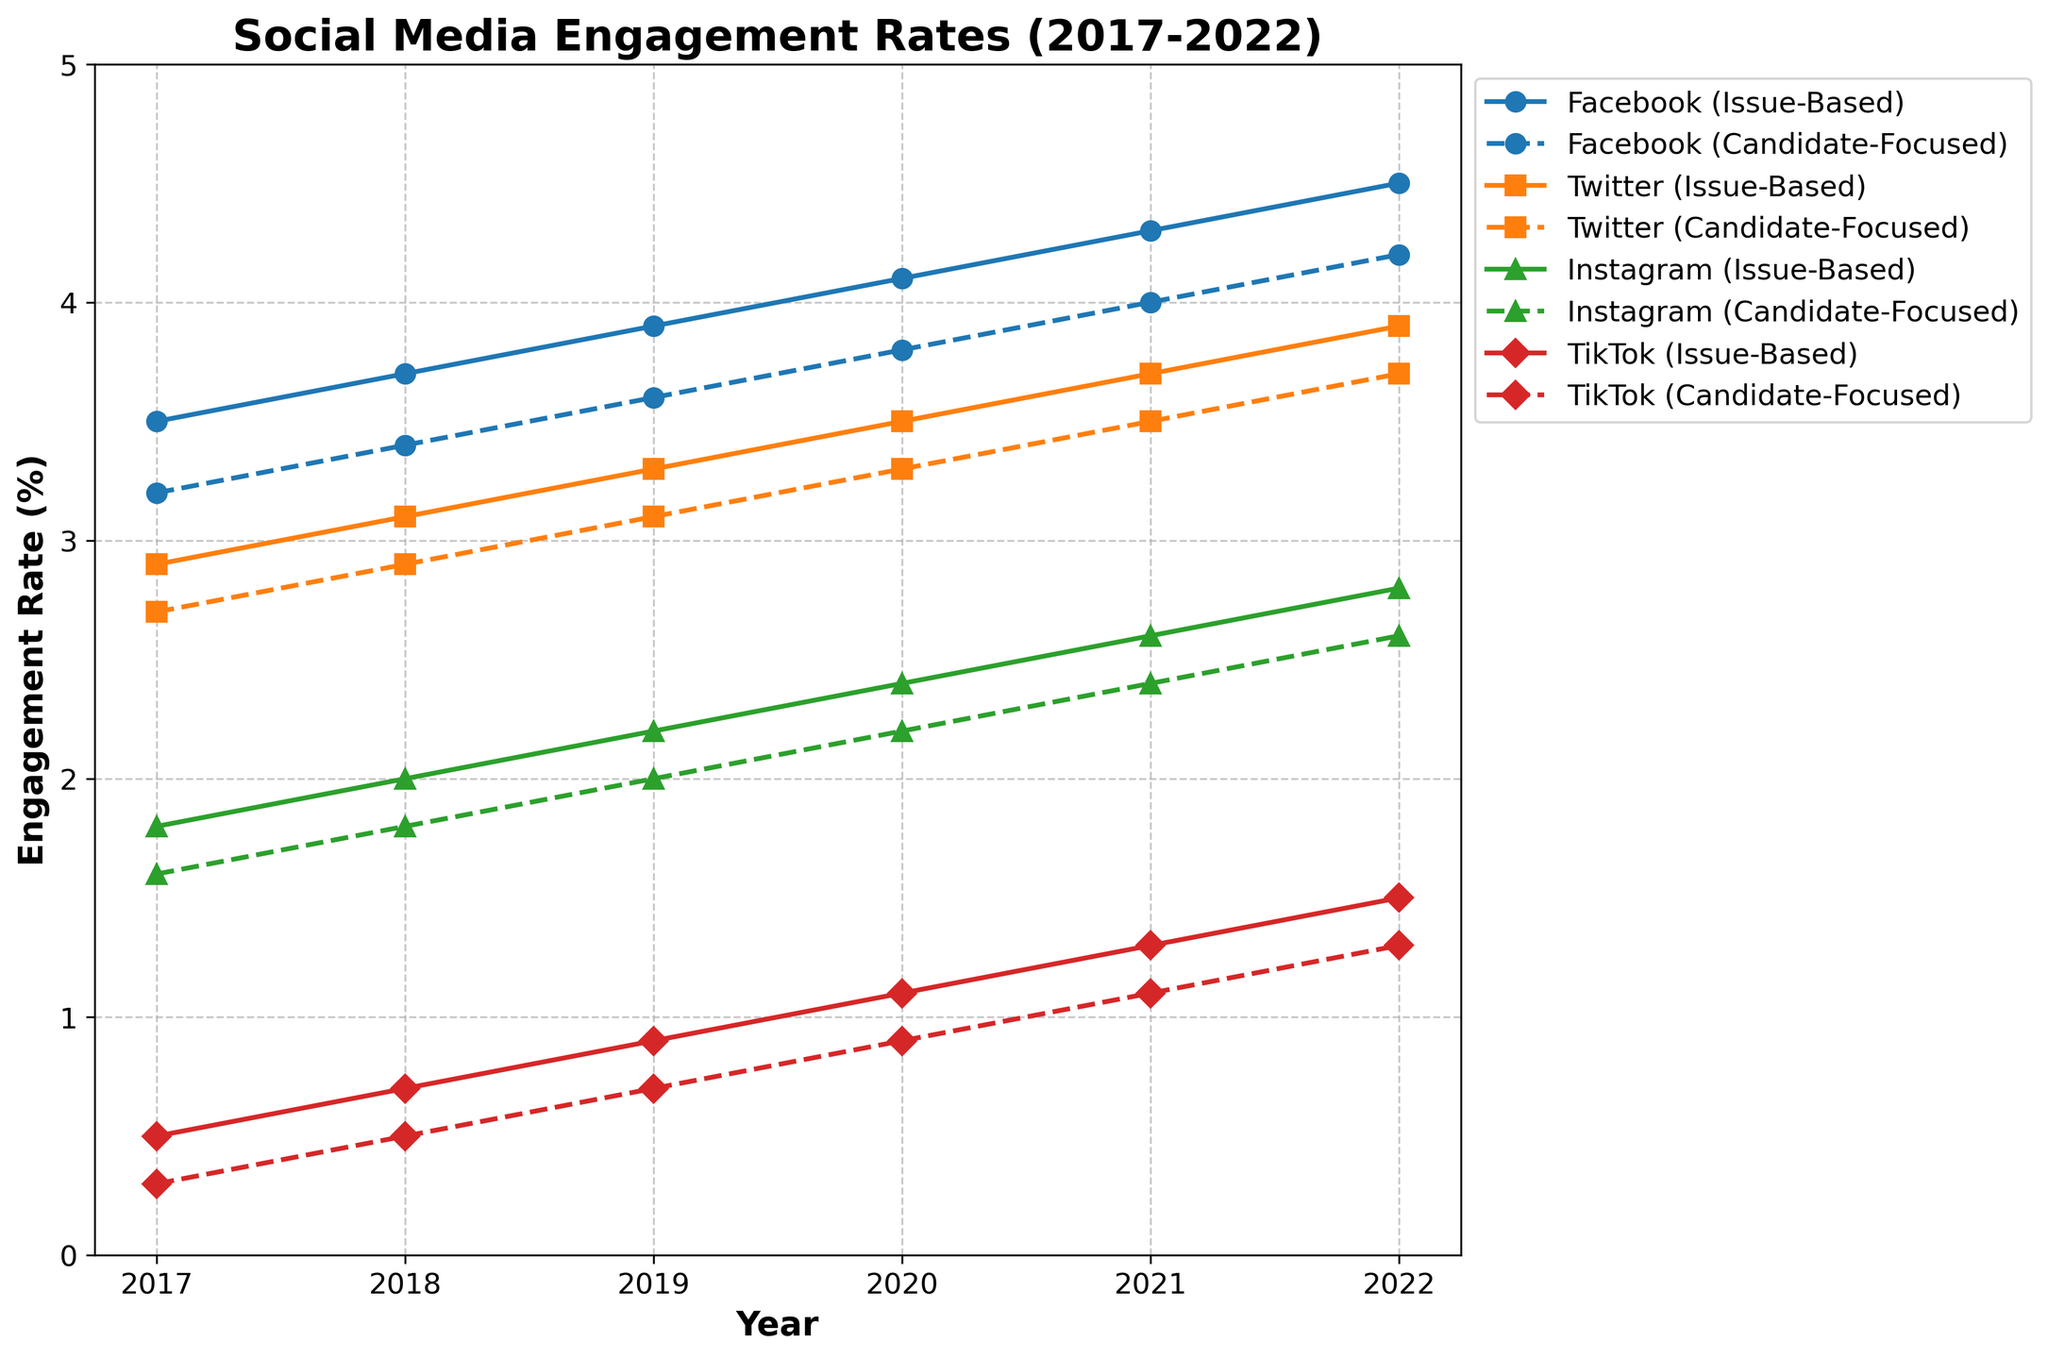What is the trend in engagement rates on Facebook for issue-based messaging from 2017 to 2022? The engagement rate on Facebook for issue-based messaging shows a steady increase from 3.5% in 2017 to 4.5% in 2022.
Answer: Increasing Which social media platform had the highest engagement rate for candidate-focused messaging in 2020? In 2020, Facebook had the highest engagement rate for candidate-focused messaging at 3.8%.
Answer: Facebook How does the engagement rate for issue-based messaging on TikTok in 2019 compare to that on Instagram in the same year? The engagement rate for issue-based messaging on TikTok in 2019 was 0.9%, while on Instagram, it was 2.2%. TikTok's rate is lower than Instagram's.
Answer: TikTok's rate is lower Is there any platform where issue-based messaging had a lower engagement rate than candidate-focused messaging in any year? Across all platforms and years from 2017 to 2022, issue-based messaging consistently shows higher engagement rates compared to candidate-focused messaging.
Answer: No Calculate the average engagement rate for Twitter on both messaging strategies combined in 2019. In 2019, the engagement rates for Twitter were 3.3% (issue-based) and 3.1% (candidate-focused). The average is (3.3 + 3.1) / 2 = 3.2%.
Answer: 3.2% Which platform shows the most significant difference in engagement rates between issue-based and candidate-focused messaging in 2022? In 2022, TikTok shows the most significant difference between issue-based (1.5%) and candidate-focused (1.3%) at 1.5 - 1.3 = 0.2%.
Answer: TikTok What is the overall trend for engagement rates on Instagram from 2017 to 2022? The engagement rates on Instagram for both issue-based and candidate-focused messaging have been steadily increasing from 2017 to 2022.
Answer: Increasing Which social media platform had the lowest engagement rate for any type of messaging in 2021? In 2021, TikTok had the lowest engagement rate for candidate-focused messaging at 1.1%.
Answer: TikTok Compare the growth in engagement rates for Facebook and Twitter's issue-based messaging from 2017 to 2022. Facebook's issue-based engagement rate grew from 3.5% to 4.5% (an increase of 1.0%), whereas Twitter's issue-based engagement rate grew from 2.9% to 3.9% (an increase of 1.0%). Both platforms had equal growth in engagement rates.
Answer: Equal growth 